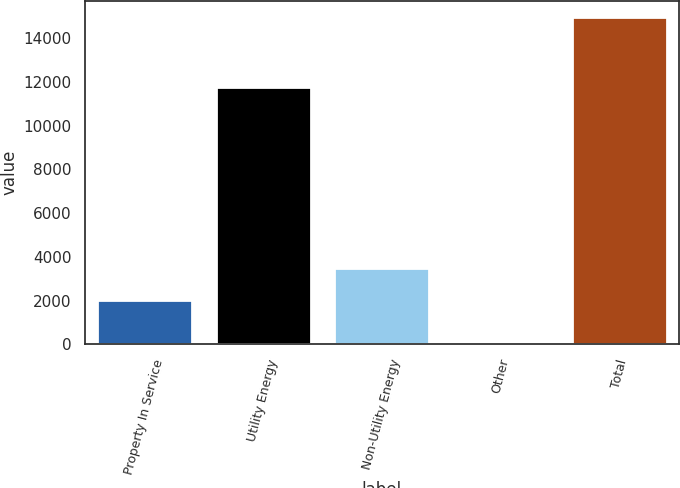Convert chart. <chart><loc_0><loc_0><loc_500><loc_500><bar_chart><fcel>Property In Service<fcel>Utility Energy<fcel>Non-Utility Energy<fcel>Other<fcel>Total<nl><fcel>2013<fcel>11779.8<fcel>3500.11<fcel>95.2<fcel>14966.3<nl></chart> 